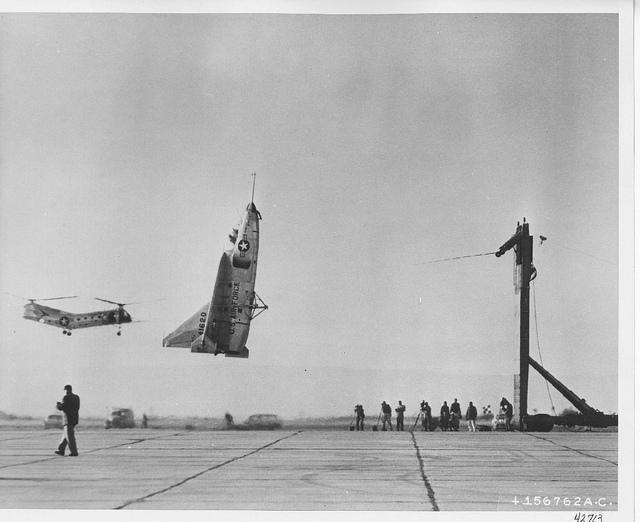How many airplanes are visible?
Give a very brief answer. 2. How many slices of pizza are missing from the whole?
Give a very brief answer. 0. 